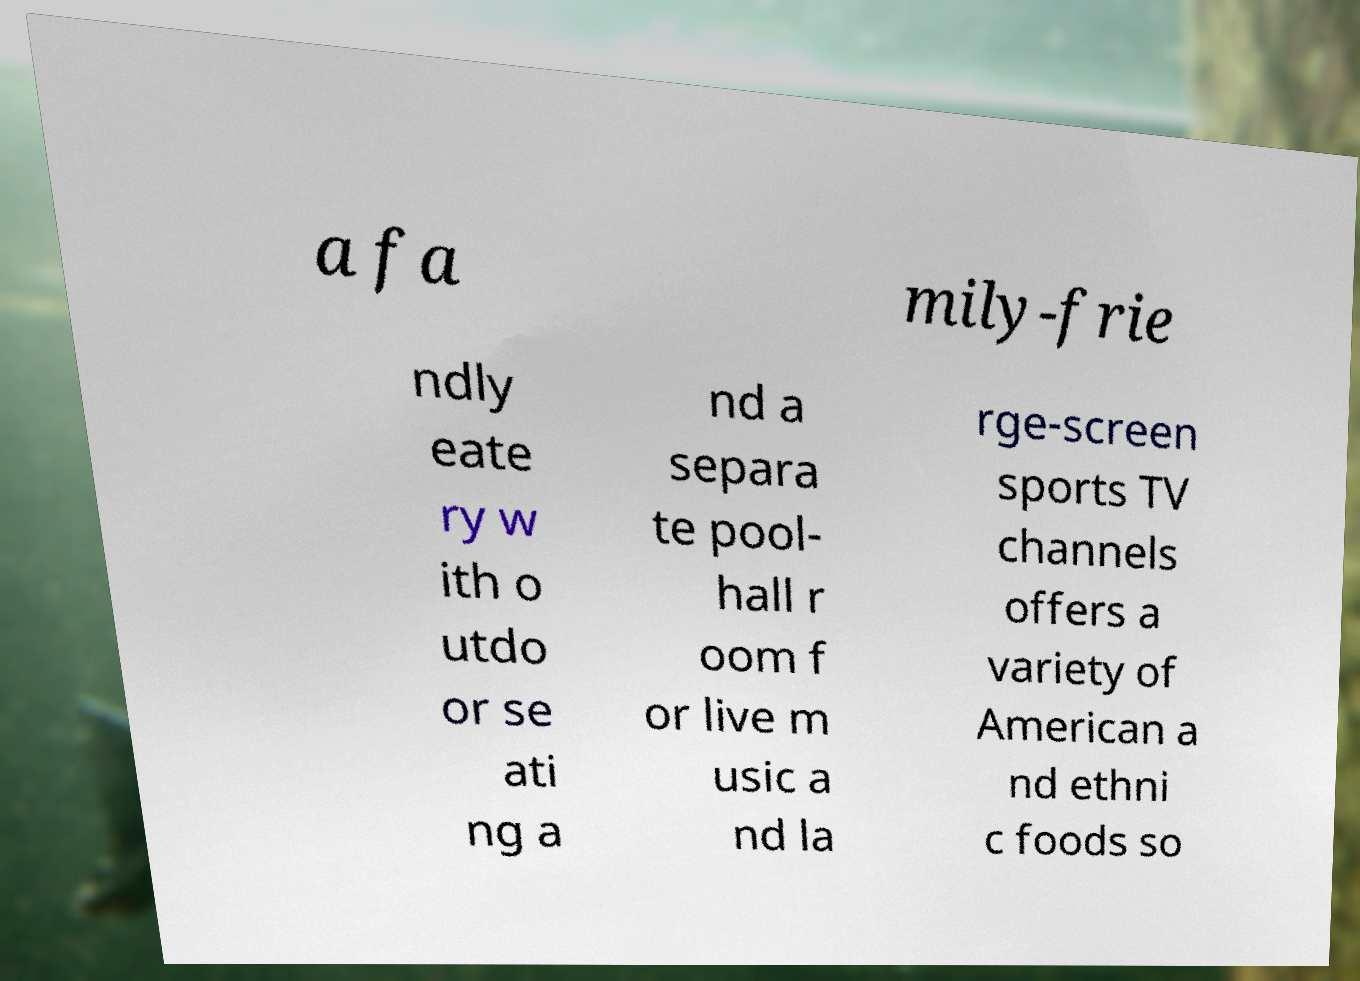Please identify and transcribe the text found in this image. a fa mily-frie ndly eate ry w ith o utdo or se ati ng a nd a separa te pool- hall r oom f or live m usic a nd la rge-screen sports TV channels offers a variety of American a nd ethni c foods so 